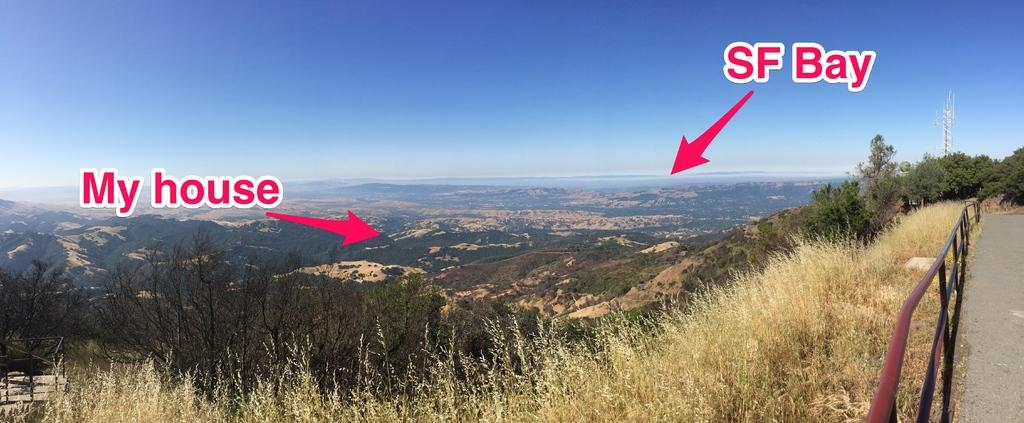<image>
Give a short and clear explanation of the subsequent image. SF bay and someones house are marked on the photo 